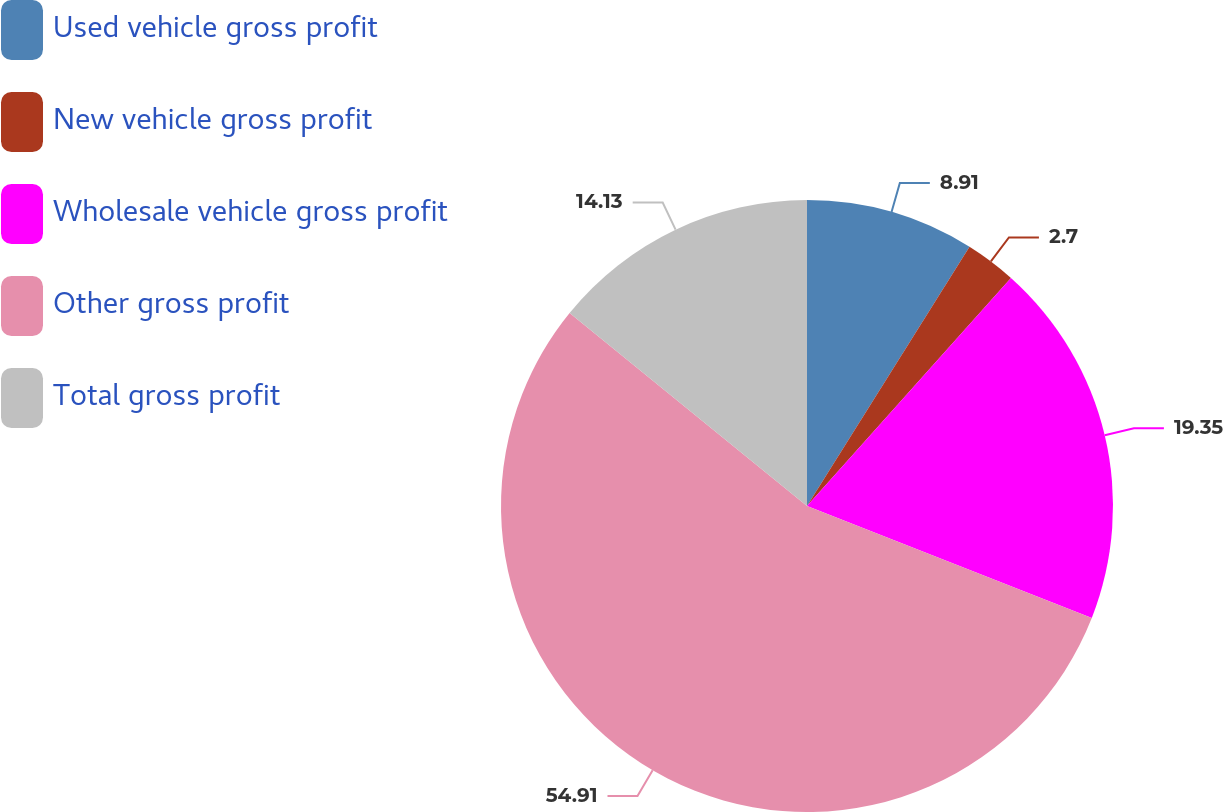Convert chart to OTSL. <chart><loc_0><loc_0><loc_500><loc_500><pie_chart><fcel>Used vehicle gross profit<fcel>New vehicle gross profit<fcel>Wholesale vehicle gross profit<fcel>Other gross profit<fcel>Total gross profit<nl><fcel>8.91%<fcel>2.7%<fcel>19.35%<fcel>54.9%<fcel>14.13%<nl></chart> 